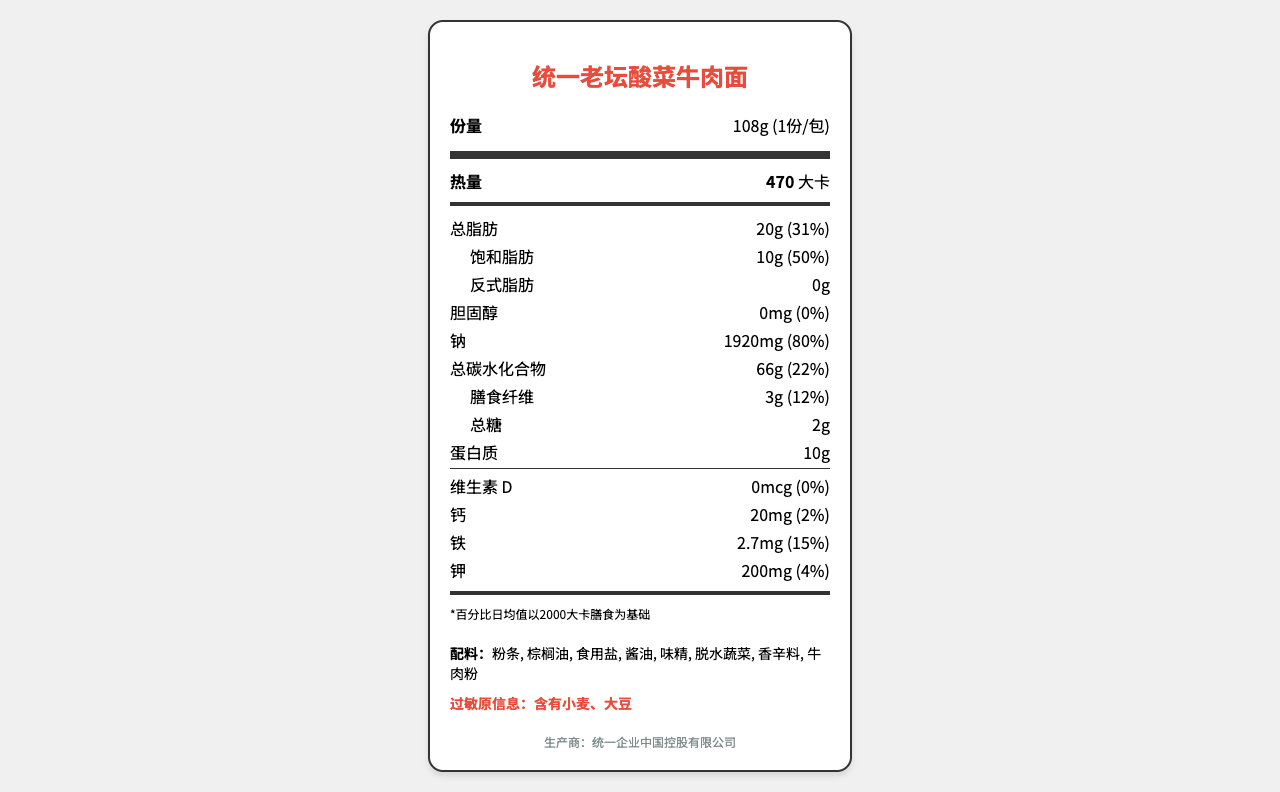what is the serving size of the product? The serving size is indicated as "份量" which is given as 108g.
Answer: 108g how many calories are there in one serving of the product? The document specifies that there are 470 calories per serving.
Answer: 470 what is the amount of sodium per serving? The sodium content is listed as 1920mg.
Answer: 1920mg what are the main ingredients listed? These ingredients are listed in the ingredient section of the document.
Answer: 粉条, 棕榈油, 食用盐, 酱油, 味精, 脱水蔬菜, 香辛料, 牛肉粉 what is the daily value percentage of total fat? The daily value percentage for total fat is listed as 31%.
Answer: 31% what is the recommended daily value percentage for sodium according to this document? A. 50% B. 60% C. 70% D. 80% The document lists the daily value percentage for sodium as 80%.
Answer: D. 80% what is the primary demographic for this product? A. Children B. Elderly C. White-collar workers and students aged 18-35 D. Athletes The consumer demographic is mentioned in the document as "18-35岁白领和学生".
Answer: C. White-collar workers and students aged 18-35 is the product high in cholesterol? The cholesterol content is listed as 0mg, which is 0% of the daily value.
Answer: No summarize the key nutritional information provided in the document. This summary includes the essential nutritional details like calories, fat, sodium, carbohydrate, protein, and main ingredients.
Answer: The product, 统一老坛酸菜牛肉面, has a serving size of 108g and provides 470 calories per serving. It contains 20g of total fat (31% DV), 10g of saturated fat (50% DV), 1920mg of sodium (80% DV), 66g of total carbohydrates (22% DV), and 10g of protein. It is made from 粉条, 棕榈油, 食用盐, and other ingredients. There are no significant amounts of vitamin D, calcium, and cholesterol. what is the regulatory compliance standard for the product? The document states that the product complies with Chinese food safety standard GB 7718-2011.
Answer: 符合中国食品安全国家标准GB 7718-2011 what is the percentage of daily value for dietary fiber? The daily value percentage for dietary fiber is indicated as 12%.
Answer: 12% what is the amount of protein per serving? The document specifies that the product contains 10g of protein per serving.
Answer: 10g is there information on the annual revenue of the manufacturer? The document mentions the annual revenue as 42亿元.
Answer: Yes can the exact amount of sugar be determined from the document? The document lists the amount of total sugars as 2g.
Answer: Yes what is the possible health impact mentioned for high sodium content? The document states that the high sodium content may increase the risk of cardiovascular diseases.
Answer: Increases the risk of cardiovascular diseases what is the manufacturer of the product? The document lists the manufacturer as 统一企业中国控股有限公司.
Answer: 统一企业中国控股有限公司 does the document mention the market share of the product? The market share is mentioned as 23.5%.
Answer: Yes how much iron is there per serving, and what is its daily value percentage? The amount of iron per serving is 2.7mg, which is 15% of the daily value.
Answer: 2.7mg; 15% what is the amount of trans fat in the product? The document lists the trans fat as 0g.
Answer: 0g does the document detail the vitamin content in the product? The document specifies the vitamin D content as 0mcg, which is 0% of the daily value.
Answer: Yes what is the capital investment of the manufacturer? The document does not provide any details about the capital investment of the manufacturer.
Answer: Not enough information 